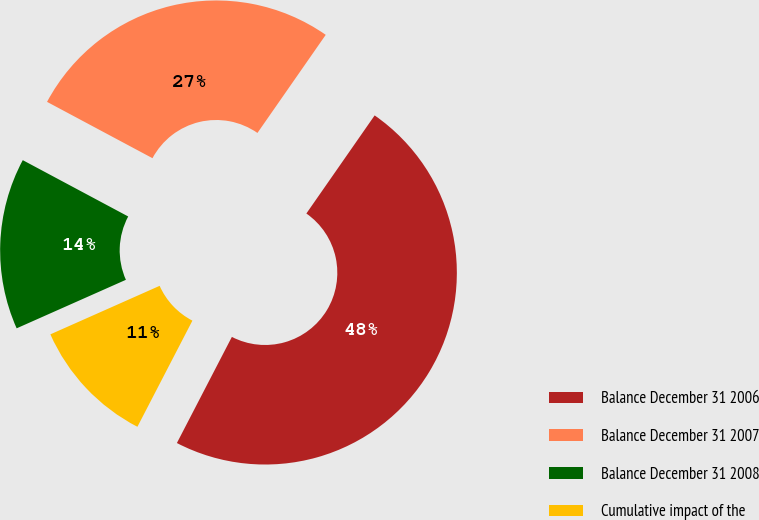Convert chart. <chart><loc_0><loc_0><loc_500><loc_500><pie_chart><fcel>Balance December 31 2006<fcel>Balance December 31 2007<fcel>Balance December 31 2008<fcel>Cumulative impact of the<nl><fcel>47.93%<fcel>26.87%<fcel>14.46%<fcel>10.74%<nl></chart> 